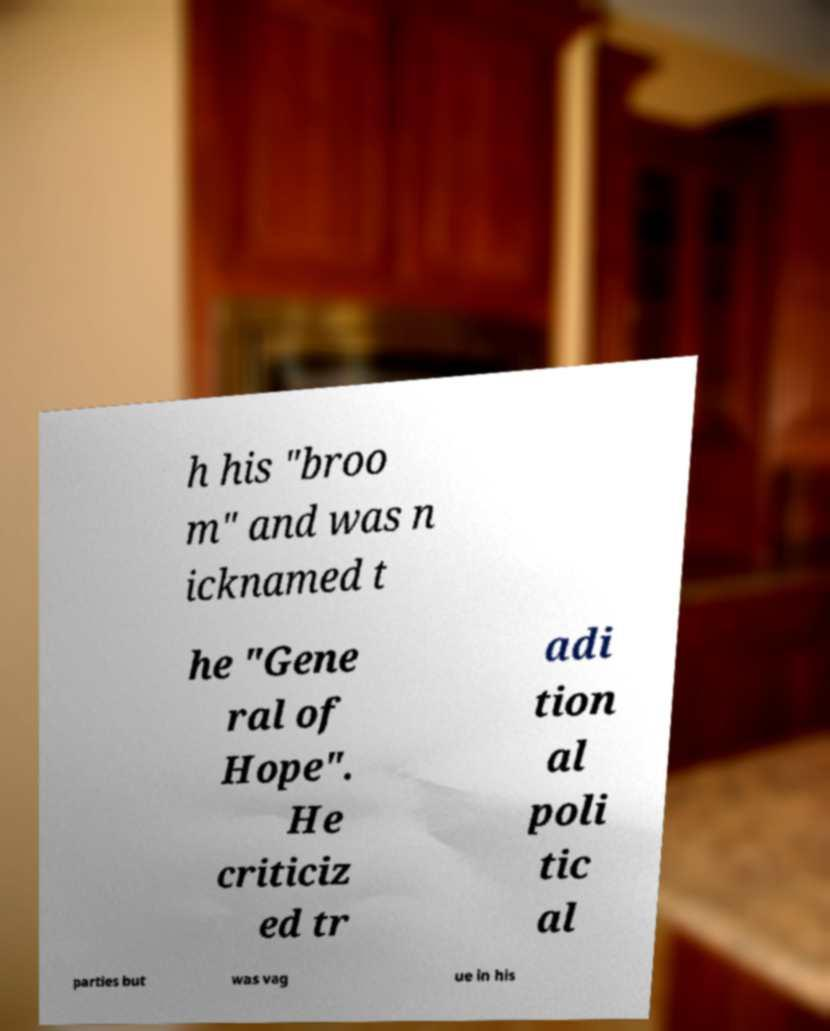Can you read and provide the text displayed in the image?This photo seems to have some interesting text. Can you extract and type it out for me? h his "broo m" and was n icknamed t he "Gene ral of Hope". He criticiz ed tr adi tion al poli tic al parties but was vag ue in his 